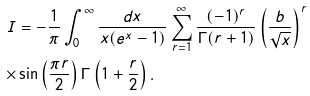<formula> <loc_0><loc_0><loc_500><loc_500>I & = - \frac { 1 } { \pi } \int _ { 0 } ^ { \infty } \frac { d x } { x ( e ^ { x } - 1 ) } \sum _ { r = 1 } ^ { \infty } \frac { ( - 1 ) ^ { r } } { \Gamma ( r + 1 ) } \left ( \frac { b } { \sqrt { x } } \right ) ^ { r } \\ \times & \sin \left ( \frac { \pi r } { 2 } \right ) \Gamma \left ( 1 + \frac { r } { 2 } \right ) .</formula> 